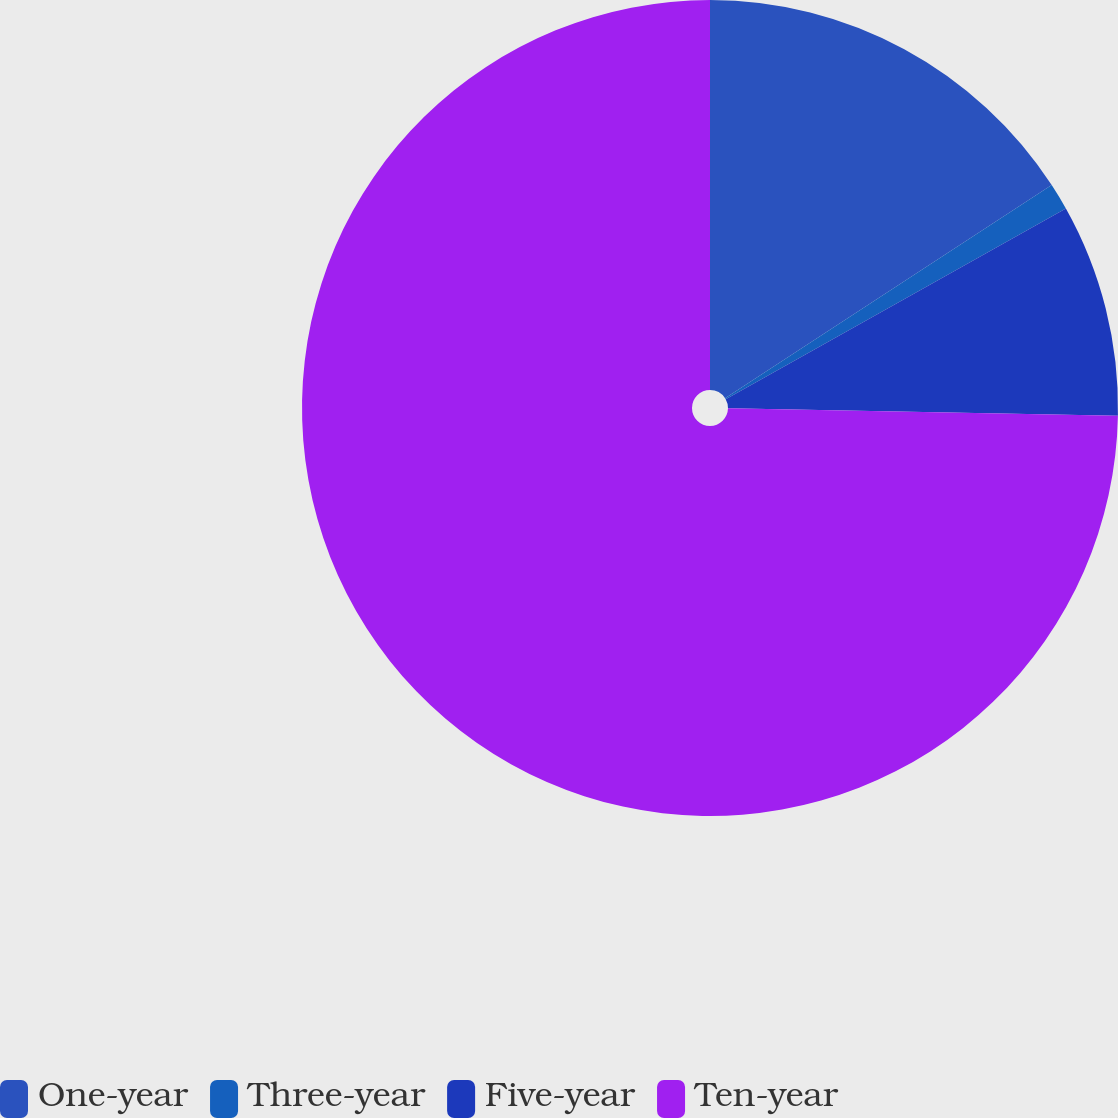Convert chart. <chart><loc_0><loc_0><loc_500><loc_500><pie_chart><fcel>One-year<fcel>Three-year<fcel>Five-year<fcel>Ten-year<nl><fcel>15.8%<fcel>1.07%<fcel>8.43%<fcel>74.71%<nl></chart> 